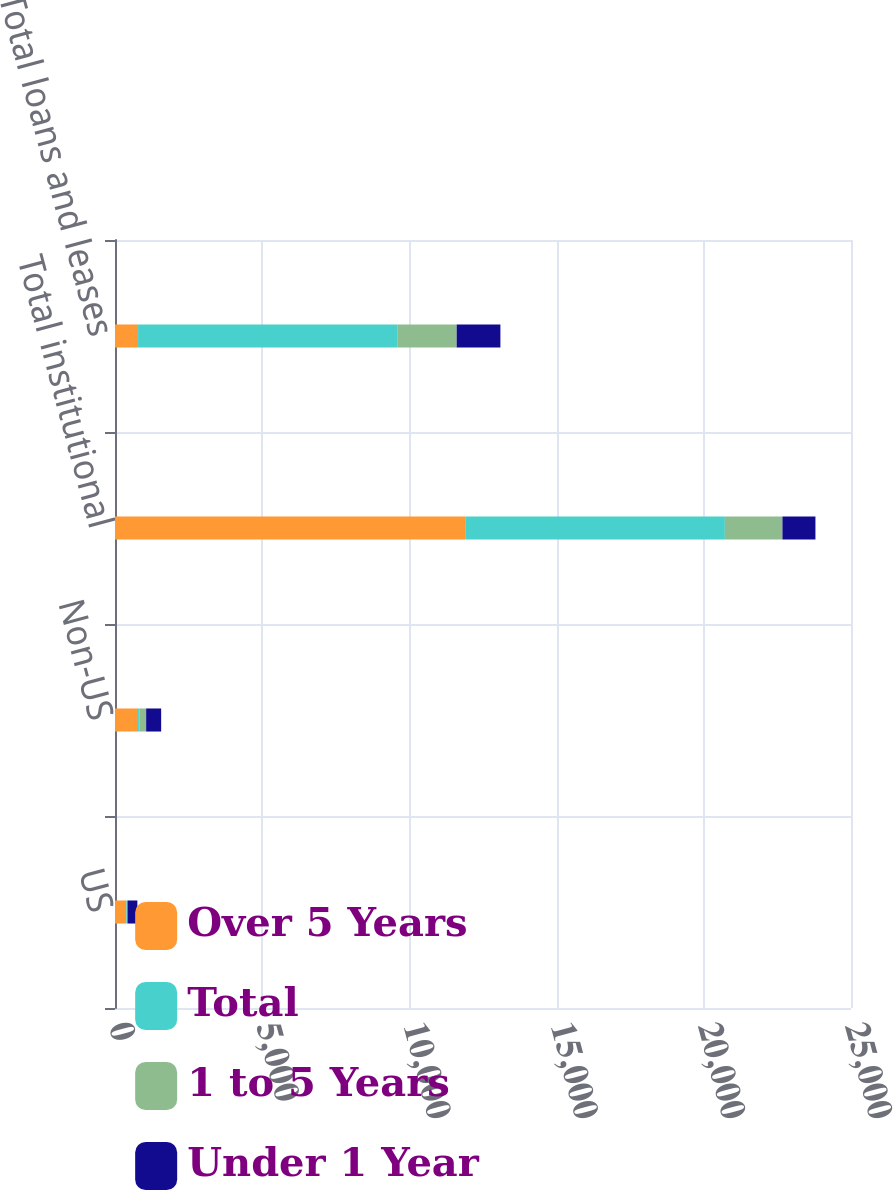Convert chart. <chart><loc_0><loc_0><loc_500><loc_500><stacked_bar_chart><ecel><fcel>US<fcel>Non-US<fcel>Total institutional<fcel>Total loans and leases<nl><fcel>Over 5 Years<fcel>380<fcel>784<fcel>11896<fcel>784<nl><fcel>Total<fcel>22<fcel>39<fcel>8820<fcel>8820<nl><fcel>1 to 5 Years<fcel>23<fcel>235<fcel>1955<fcel>2002<nl><fcel>Under 1 Year<fcel>335<fcel>510<fcel>1121<fcel>1485<nl></chart> 